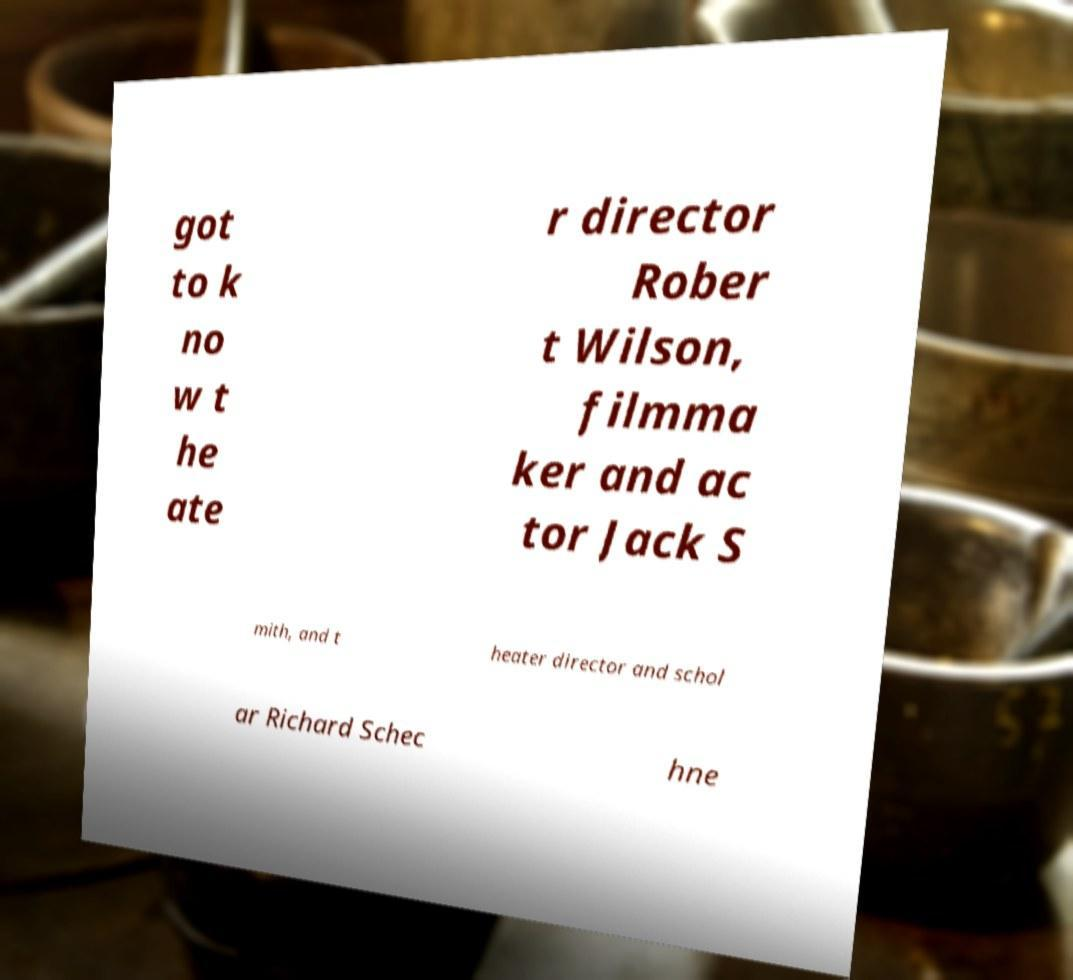Could you assist in decoding the text presented in this image and type it out clearly? got to k no w t he ate r director Rober t Wilson, filmma ker and ac tor Jack S mith, and t heater director and schol ar Richard Schec hne 